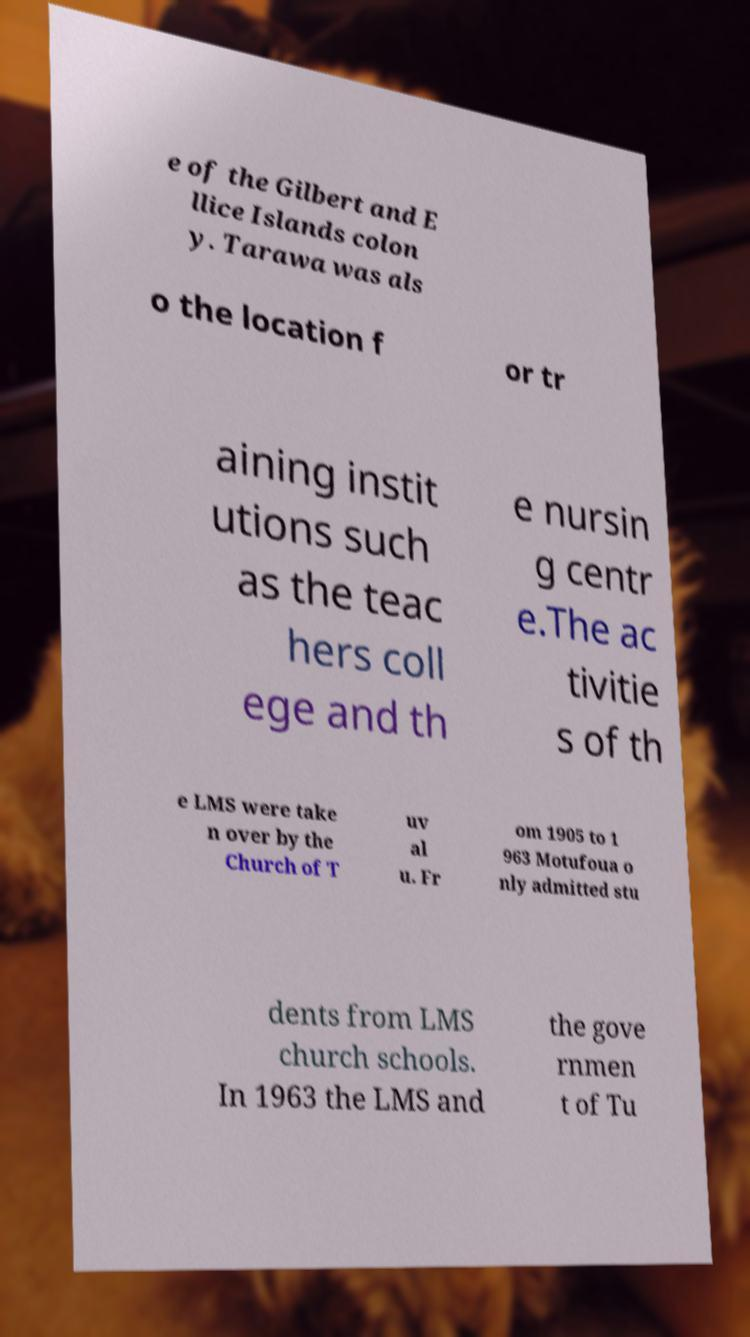I need the written content from this picture converted into text. Can you do that? e of the Gilbert and E llice Islands colon y. Tarawa was als o the location f or tr aining instit utions such as the teac hers coll ege and th e nursin g centr e.The ac tivitie s of th e LMS were take n over by the Church of T uv al u. Fr om 1905 to 1 963 Motufoua o nly admitted stu dents from LMS church schools. In 1963 the LMS and the gove rnmen t of Tu 